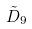Convert formula to latex. <formula><loc_0><loc_0><loc_500><loc_500>\tilde { D } _ { 9 }</formula> 